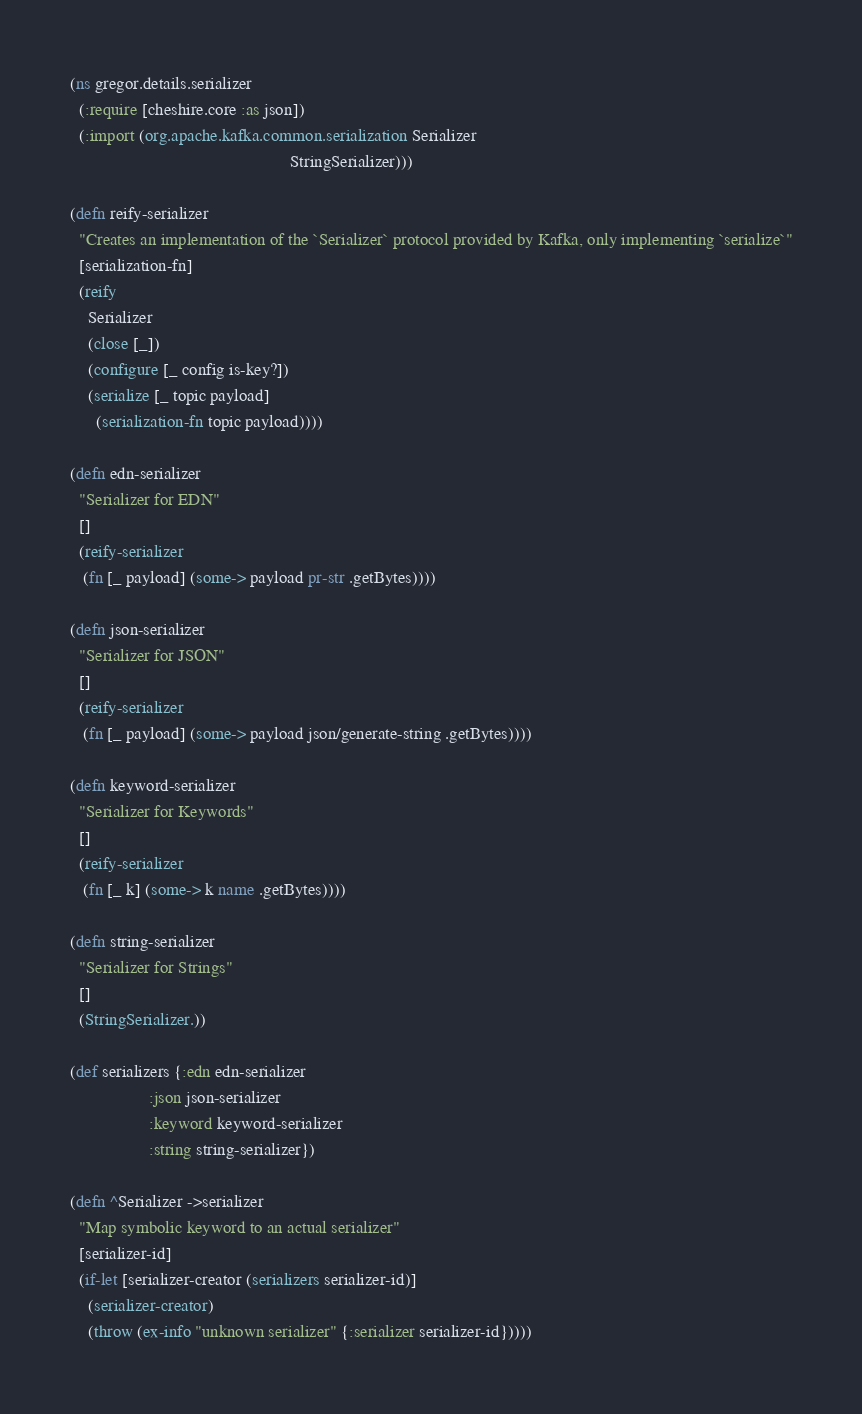Convert code to text. <code><loc_0><loc_0><loc_500><loc_500><_Clojure_>(ns gregor.details.serializer
  (:require [cheshire.core :as json])
  (:import (org.apache.kafka.common.serialization Serializer
                                                  StringSerializer)))

(defn reify-serializer
  "Creates an implementation of the `Serializer` protocol provided by Kafka, only implementing `serialize`"
  [serialization-fn]
  (reify
    Serializer
    (close [_])
    (configure [_ config is-key?])
    (serialize [_ topic payload]
      (serialization-fn topic payload))))

(defn edn-serializer
  "Serializer for EDN"
  []
  (reify-serializer
   (fn [_ payload] (some-> payload pr-str .getBytes))))

(defn json-serializer
  "Serializer for JSON"
  []
  (reify-serializer
   (fn [_ payload] (some-> payload json/generate-string .getBytes))))

(defn keyword-serializer
  "Serializer for Keywords"
  []
  (reify-serializer
   (fn [_ k] (some-> k name .getBytes))))

(defn string-serializer
  "Serializer for Strings"
  []
  (StringSerializer.))

(def serializers {:edn edn-serializer
                  :json json-serializer
                  :keyword keyword-serializer
                  :string string-serializer})

(defn ^Serializer ->serializer
  "Map symbolic keyword to an actual serializer"
  [serializer-id]
  (if-let [serializer-creator (serializers serializer-id)]
    (serializer-creator)
    (throw (ex-info "unknown serializer" {:serializer serializer-id}))))
</code> 